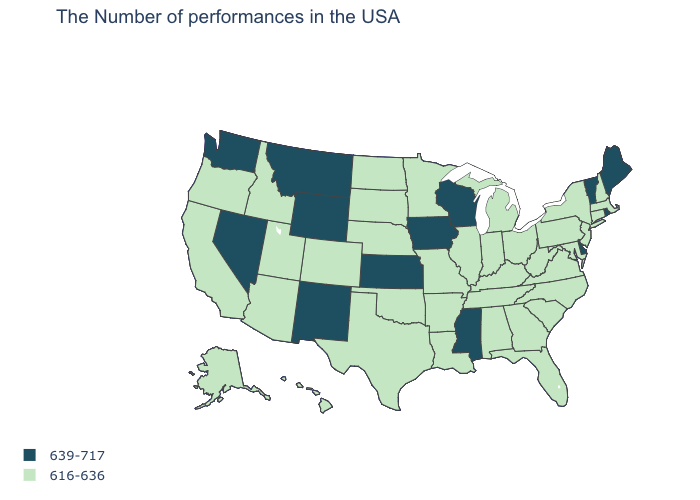What is the value of Idaho?
Quick response, please. 616-636. Which states hav the highest value in the West?
Quick response, please. Wyoming, New Mexico, Montana, Nevada, Washington. Among the states that border Oregon , which have the highest value?
Write a very short answer. Nevada, Washington. Does South Carolina have the same value as Florida?
Concise answer only. Yes. Is the legend a continuous bar?
Give a very brief answer. No. Name the states that have a value in the range 616-636?
Answer briefly. Massachusetts, New Hampshire, Connecticut, New York, New Jersey, Maryland, Pennsylvania, Virginia, North Carolina, South Carolina, West Virginia, Ohio, Florida, Georgia, Michigan, Kentucky, Indiana, Alabama, Tennessee, Illinois, Louisiana, Missouri, Arkansas, Minnesota, Nebraska, Oklahoma, Texas, South Dakota, North Dakota, Colorado, Utah, Arizona, Idaho, California, Oregon, Alaska, Hawaii. Name the states that have a value in the range 616-636?
Short answer required. Massachusetts, New Hampshire, Connecticut, New York, New Jersey, Maryland, Pennsylvania, Virginia, North Carolina, South Carolina, West Virginia, Ohio, Florida, Georgia, Michigan, Kentucky, Indiana, Alabama, Tennessee, Illinois, Louisiana, Missouri, Arkansas, Minnesota, Nebraska, Oklahoma, Texas, South Dakota, North Dakota, Colorado, Utah, Arizona, Idaho, California, Oregon, Alaska, Hawaii. Which states have the lowest value in the South?
Short answer required. Maryland, Virginia, North Carolina, South Carolina, West Virginia, Florida, Georgia, Kentucky, Alabama, Tennessee, Louisiana, Arkansas, Oklahoma, Texas. Does Kentucky have a higher value than Iowa?
Write a very short answer. No. Among the states that border Arizona , does Utah have the lowest value?
Quick response, please. Yes. Does Washington have the lowest value in the West?
Give a very brief answer. No. Does the map have missing data?
Concise answer only. No. What is the value of Oklahoma?
Short answer required. 616-636. Does Iowa have a higher value than Montana?
Answer briefly. No. Name the states that have a value in the range 616-636?
Give a very brief answer. Massachusetts, New Hampshire, Connecticut, New York, New Jersey, Maryland, Pennsylvania, Virginia, North Carolina, South Carolina, West Virginia, Ohio, Florida, Georgia, Michigan, Kentucky, Indiana, Alabama, Tennessee, Illinois, Louisiana, Missouri, Arkansas, Minnesota, Nebraska, Oklahoma, Texas, South Dakota, North Dakota, Colorado, Utah, Arizona, Idaho, California, Oregon, Alaska, Hawaii. 